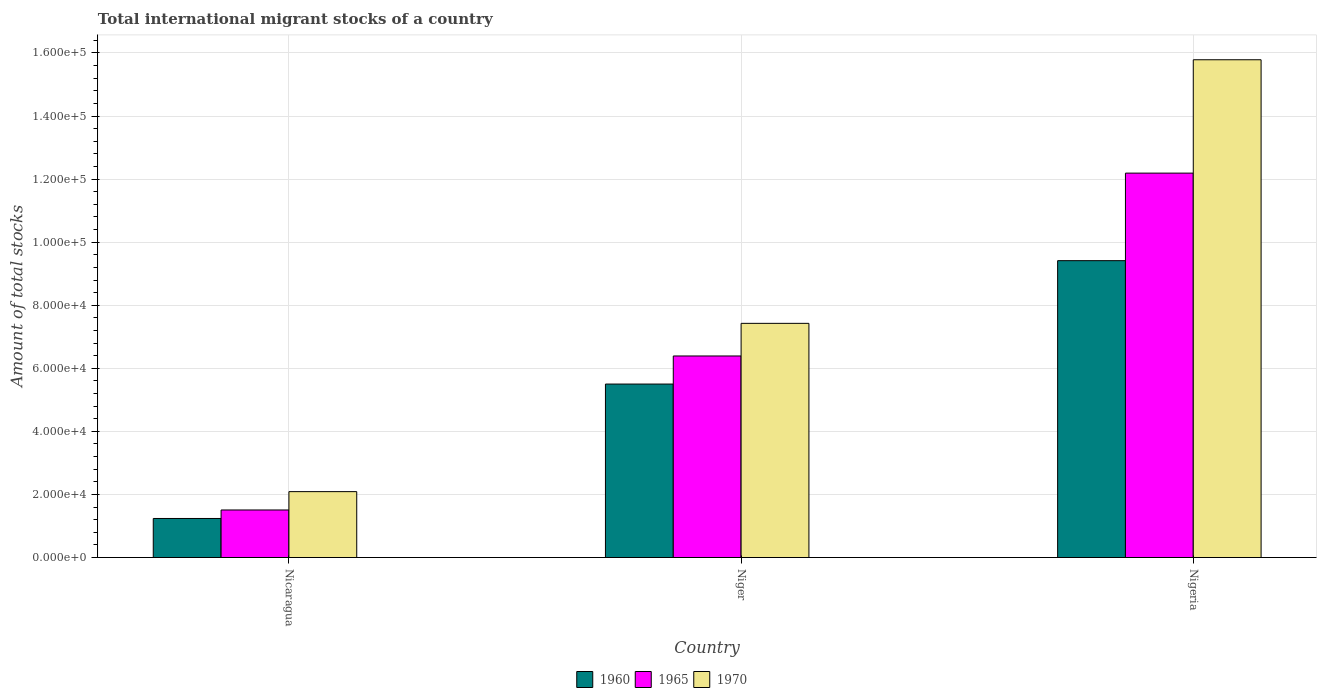How many groups of bars are there?
Your answer should be very brief. 3. Are the number of bars per tick equal to the number of legend labels?
Offer a terse response. Yes. How many bars are there on the 2nd tick from the right?
Offer a terse response. 3. What is the label of the 1st group of bars from the left?
Ensure brevity in your answer.  Nicaragua. In how many cases, is the number of bars for a given country not equal to the number of legend labels?
Your response must be concise. 0. What is the amount of total stocks in in 1960 in Nigeria?
Provide a short and direct response. 9.41e+04. Across all countries, what is the maximum amount of total stocks in in 1965?
Offer a very short reply. 1.22e+05. Across all countries, what is the minimum amount of total stocks in in 1960?
Keep it short and to the point. 1.24e+04. In which country was the amount of total stocks in in 1960 maximum?
Your answer should be compact. Nigeria. In which country was the amount of total stocks in in 1965 minimum?
Make the answer very short. Nicaragua. What is the total amount of total stocks in in 1965 in the graph?
Your answer should be compact. 2.01e+05. What is the difference between the amount of total stocks in in 1965 in Nicaragua and that in Niger?
Provide a succinct answer. -4.88e+04. What is the difference between the amount of total stocks in in 1965 in Niger and the amount of total stocks in in 1970 in Nicaragua?
Give a very brief answer. 4.30e+04. What is the average amount of total stocks in in 1960 per country?
Offer a terse response. 5.38e+04. What is the difference between the amount of total stocks in of/in 1970 and amount of total stocks in of/in 1960 in Nicaragua?
Provide a short and direct response. 8512. What is the ratio of the amount of total stocks in in 1960 in Nicaragua to that in Niger?
Your answer should be very brief. 0.23. Is the amount of total stocks in in 1965 in Nicaragua less than that in Nigeria?
Keep it short and to the point. Yes. What is the difference between the highest and the second highest amount of total stocks in in 1970?
Provide a short and direct response. -1.37e+05. What is the difference between the highest and the lowest amount of total stocks in in 1965?
Keep it short and to the point. 1.07e+05. In how many countries, is the amount of total stocks in in 1965 greater than the average amount of total stocks in in 1965 taken over all countries?
Give a very brief answer. 1. Is the sum of the amount of total stocks in in 1970 in Niger and Nigeria greater than the maximum amount of total stocks in in 1965 across all countries?
Your answer should be very brief. Yes. What does the 2nd bar from the left in Nigeria represents?
Give a very brief answer. 1965. What does the 2nd bar from the right in Nicaragua represents?
Ensure brevity in your answer.  1965. Are all the bars in the graph horizontal?
Provide a short and direct response. No. How many countries are there in the graph?
Your answer should be very brief. 3. Are the values on the major ticks of Y-axis written in scientific E-notation?
Make the answer very short. Yes. Does the graph contain grids?
Make the answer very short. Yes. Where does the legend appear in the graph?
Give a very brief answer. Bottom center. How many legend labels are there?
Provide a short and direct response. 3. What is the title of the graph?
Provide a short and direct response. Total international migrant stocks of a country. What is the label or title of the Y-axis?
Provide a short and direct response. Amount of total stocks. What is the Amount of total stocks of 1960 in Nicaragua?
Give a very brief answer. 1.24e+04. What is the Amount of total stocks in 1965 in Nicaragua?
Your response must be concise. 1.51e+04. What is the Amount of total stocks in 1970 in Nicaragua?
Offer a terse response. 2.09e+04. What is the Amount of total stocks in 1960 in Niger?
Offer a terse response. 5.50e+04. What is the Amount of total stocks of 1965 in Niger?
Give a very brief answer. 6.39e+04. What is the Amount of total stocks of 1970 in Niger?
Keep it short and to the point. 7.43e+04. What is the Amount of total stocks in 1960 in Nigeria?
Offer a terse response. 9.41e+04. What is the Amount of total stocks in 1965 in Nigeria?
Your response must be concise. 1.22e+05. What is the Amount of total stocks in 1970 in Nigeria?
Offer a terse response. 1.58e+05. Across all countries, what is the maximum Amount of total stocks in 1960?
Make the answer very short. 9.41e+04. Across all countries, what is the maximum Amount of total stocks in 1965?
Give a very brief answer. 1.22e+05. Across all countries, what is the maximum Amount of total stocks of 1970?
Your answer should be compact. 1.58e+05. Across all countries, what is the minimum Amount of total stocks of 1960?
Offer a very short reply. 1.24e+04. Across all countries, what is the minimum Amount of total stocks of 1965?
Your response must be concise. 1.51e+04. Across all countries, what is the minimum Amount of total stocks of 1970?
Keep it short and to the point. 2.09e+04. What is the total Amount of total stocks in 1960 in the graph?
Make the answer very short. 1.62e+05. What is the total Amount of total stocks in 1965 in the graph?
Your answer should be very brief. 2.01e+05. What is the total Amount of total stocks in 1970 in the graph?
Give a very brief answer. 2.53e+05. What is the difference between the Amount of total stocks of 1960 in Nicaragua and that in Niger?
Give a very brief answer. -4.26e+04. What is the difference between the Amount of total stocks of 1965 in Nicaragua and that in Niger?
Ensure brevity in your answer.  -4.88e+04. What is the difference between the Amount of total stocks in 1970 in Nicaragua and that in Niger?
Provide a short and direct response. -5.34e+04. What is the difference between the Amount of total stocks in 1960 in Nicaragua and that in Nigeria?
Your answer should be compact. -8.17e+04. What is the difference between the Amount of total stocks of 1965 in Nicaragua and that in Nigeria?
Provide a short and direct response. -1.07e+05. What is the difference between the Amount of total stocks in 1970 in Nicaragua and that in Nigeria?
Your answer should be compact. -1.37e+05. What is the difference between the Amount of total stocks in 1960 in Niger and that in Nigeria?
Provide a short and direct response. -3.91e+04. What is the difference between the Amount of total stocks in 1965 in Niger and that in Nigeria?
Your response must be concise. -5.80e+04. What is the difference between the Amount of total stocks of 1970 in Niger and that in Nigeria?
Provide a short and direct response. -8.36e+04. What is the difference between the Amount of total stocks of 1960 in Nicaragua and the Amount of total stocks of 1965 in Niger?
Your answer should be compact. -5.15e+04. What is the difference between the Amount of total stocks in 1960 in Nicaragua and the Amount of total stocks in 1970 in Niger?
Your response must be concise. -6.19e+04. What is the difference between the Amount of total stocks in 1965 in Nicaragua and the Amount of total stocks in 1970 in Niger?
Make the answer very short. -5.92e+04. What is the difference between the Amount of total stocks of 1960 in Nicaragua and the Amount of total stocks of 1965 in Nigeria?
Give a very brief answer. -1.10e+05. What is the difference between the Amount of total stocks in 1960 in Nicaragua and the Amount of total stocks in 1970 in Nigeria?
Your answer should be very brief. -1.45e+05. What is the difference between the Amount of total stocks in 1965 in Nicaragua and the Amount of total stocks in 1970 in Nigeria?
Make the answer very short. -1.43e+05. What is the difference between the Amount of total stocks in 1960 in Niger and the Amount of total stocks in 1965 in Nigeria?
Offer a very short reply. -6.69e+04. What is the difference between the Amount of total stocks in 1960 in Niger and the Amount of total stocks in 1970 in Nigeria?
Your response must be concise. -1.03e+05. What is the difference between the Amount of total stocks of 1965 in Niger and the Amount of total stocks of 1970 in Nigeria?
Your response must be concise. -9.39e+04. What is the average Amount of total stocks of 1960 per country?
Ensure brevity in your answer.  5.38e+04. What is the average Amount of total stocks of 1965 per country?
Offer a terse response. 6.70e+04. What is the average Amount of total stocks in 1970 per country?
Your answer should be very brief. 8.43e+04. What is the difference between the Amount of total stocks in 1960 and Amount of total stocks in 1965 in Nicaragua?
Offer a terse response. -2695. What is the difference between the Amount of total stocks of 1960 and Amount of total stocks of 1970 in Nicaragua?
Give a very brief answer. -8512. What is the difference between the Amount of total stocks in 1965 and Amount of total stocks in 1970 in Nicaragua?
Offer a very short reply. -5817. What is the difference between the Amount of total stocks in 1960 and Amount of total stocks in 1965 in Niger?
Keep it short and to the point. -8903. What is the difference between the Amount of total stocks of 1960 and Amount of total stocks of 1970 in Niger?
Your answer should be very brief. -1.92e+04. What is the difference between the Amount of total stocks of 1965 and Amount of total stocks of 1970 in Niger?
Offer a very short reply. -1.03e+04. What is the difference between the Amount of total stocks in 1960 and Amount of total stocks in 1965 in Nigeria?
Provide a short and direct response. -2.78e+04. What is the difference between the Amount of total stocks in 1960 and Amount of total stocks in 1970 in Nigeria?
Provide a succinct answer. -6.37e+04. What is the difference between the Amount of total stocks of 1965 and Amount of total stocks of 1970 in Nigeria?
Ensure brevity in your answer.  -3.59e+04. What is the ratio of the Amount of total stocks in 1960 in Nicaragua to that in Niger?
Keep it short and to the point. 0.23. What is the ratio of the Amount of total stocks of 1965 in Nicaragua to that in Niger?
Give a very brief answer. 0.24. What is the ratio of the Amount of total stocks in 1970 in Nicaragua to that in Niger?
Your answer should be very brief. 0.28. What is the ratio of the Amount of total stocks in 1960 in Nicaragua to that in Nigeria?
Offer a terse response. 0.13. What is the ratio of the Amount of total stocks in 1965 in Nicaragua to that in Nigeria?
Give a very brief answer. 0.12. What is the ratio of the Amount of total stocks in 1970 in Nicaragua to that in Nigeria?
Keep it short and to the point. 0.13. What is the ratio of the Amount of total stocks of 1960 in Niger to that in Nigeria?
Your answer should be very brief. 0.58. What is the ratio of the Amount of total stocks in 1965 in Niger to that in Nigeria?
Your answer should be very brief. 0.52. What is the ratio of the Amount of total stocks of 1970 in Niger to that in Nigeria?
Keep it short and to the point. 0.47. What is the difference between the highest and the second highest Amount of total stocks in 1960?
Make the answer very short. 3.91e+04. What is the difference between the highest and the second highest Amount of total stocks of 1965?
Provide a succinct answer. 5.80e+04. What is the difference between the highest and the second highest Amount of total stocks of 1970?
Offer a very short reply. 8.36e+04. What is the difference between the highest and the lowest Amount of total stocks of 1960?
Make the answer very short. 8.17e+04. What is the difference between the highest and the lowest Amount of total stocks in 1965?
Ensure brevity in your answer.  1.07e+05. What is the difference between the highest and the lowest Amount of total stocks of 1970?
Provide a short and direct response. 1.37e+05. 